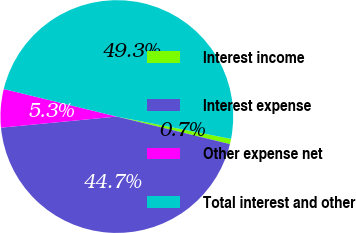<chart> <loc_0><loc_0><loc_500><loc_500><pie_chart><fcel>Interest income<fcel>Interest expense<fcel>Other expense net<fcel>Total interest and other<nl><fcel>0.73%<fcel>44.67%<fcel>5.33%<fcel>49.27%<nl></chart> 